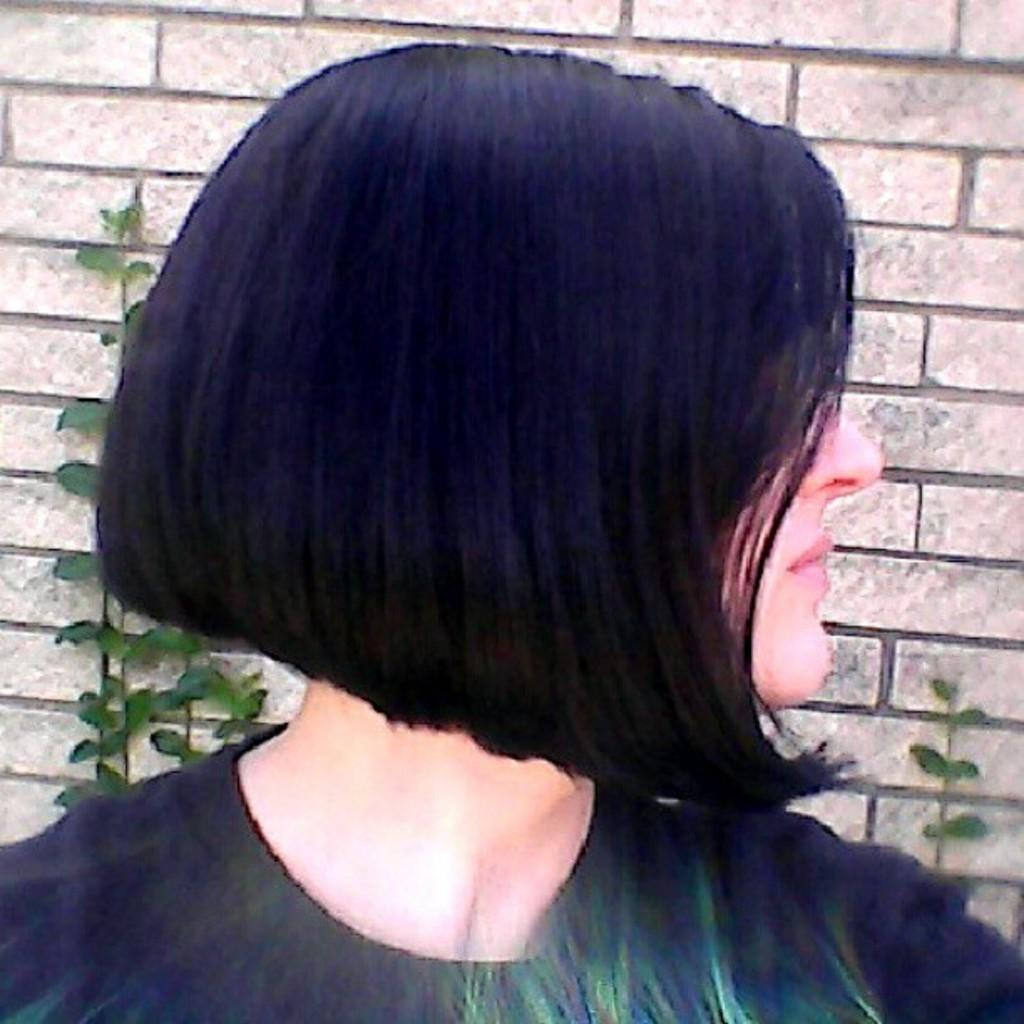Who is the main subject in the image? There is a girl in the center of the image. What can be seen behind the girl? There are plants behind the girl. Are there any fairies visible among the plants in the image? There are no fairies present in the image; only the girl and plants are visible. What type of silver object can be seen in the image? There is no silver object present in the image. 